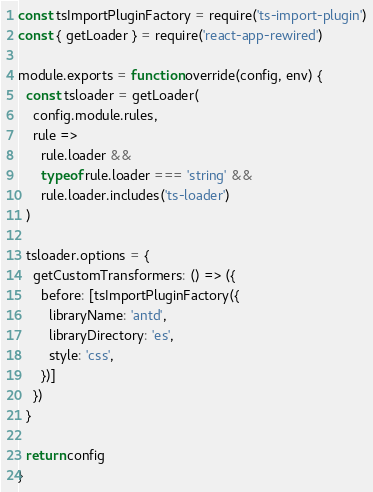Convert code to text. <code><loc_0><loc_0><loc_500><loc_500><_JavaScript_>const tsImportPluginFactory = require('ts-import-plugin')
const { getLoader } = require('react-app-rewired')

module.exports = function override(config, env) {
  const tsloader = getLoader(
    config.module.rules,
    rule =>
      rule.loader &&
      typeof rule.loader === 'string' &&
      rule.loader.includes('ts-loader')
  )

  tsloader.options = {
    getCustomTransformers: () => ({
      before: [tsImportPluginFactory({
        libraryName: 'antd',
        libraryDirectory: 'es',
        style: 'css',
      })]
    })
  }

  return config
}</code> 